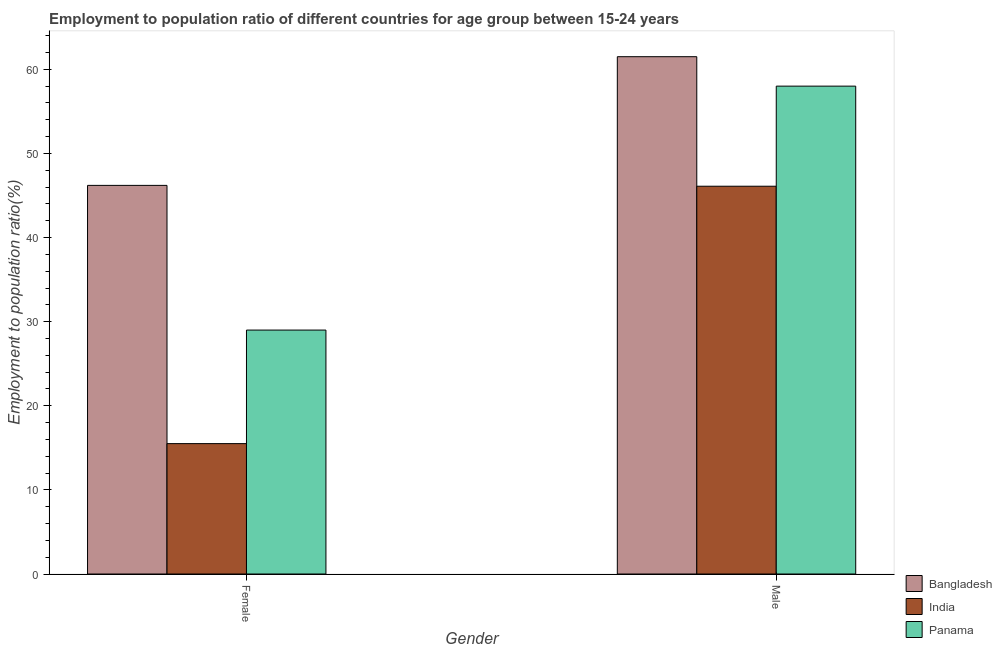How many bars are there on the 1st tick from the right?
Provide a succinct answer. 3. What is the label of the 2nd group of bars from the left?
Keep it short and to the point. Male. Across all countries, what is the maximum employment to population ratio(male)?
Make the answer very short. 61.5. Across all countries, what is the minimum employment to population ratio(male)?
Offer a terse response. 46.1. What is the total employment to population ratio(male) in the graph?
Give a very brief answer. 165.6. What is the difference between the employment to population ratio(female) in India and that in Panama?
Your response must be concise. -13.5. What is the difference between the employment to population ratio(female) in Panama and the employment to population ratio(male) in Bangladesh?
Give a very brief answer. -32.5. What is the average employment to population ratio(female) per country?
Your answer should be very brief. 30.23. What is the difference between the employment to population ratio(male) and employment to population ratio(female) in Bangladesh?
Offer a very short reply. 15.3. What is the ratio of the employment to population ratio(male) in Panama to that in Bangladesh?
Keep it short and to the point. 0.94. Is the employment to population ratio(male) in India less than that in Bangladesh?
Your answer should be very brief. Yes. In how many countries, is the employment to population ratio(male) greater than the average employment to population ratio(male) taken over all countries?
Make the answer very short. 2. How many countries are there in the graph?
Make the answer very short. 3. What is the difference between two consecutive major ticks on the Y-axis?
Give a very brief answer. 10. Are the values on the major ticks of Y-axis written in scientific E-notation?
Your answer should be very brief. No. Does the graph contain any zero values?
Your answer should be very brief. No. What is the title of the graph?
Keep it short and to the point. Employment to population ratio of different countries for age group between 15-24 years. Does "Greece" appear as one of the legend labels in the graph?
Provide a short and direct response. No. What is the label or title of the X-axis?
Give a very brief answer. Gender. What is the label or title of the Y-axis?
Offer a terse response. Employment to population ratio(%). What is the Employment to population ratio(%) in Bangladesh in Female?
Offer a very short reply. 46.2. What is the Employment to population ratio(%) of Panama in Female?
Offer a very short reply. 29. What is the Employment to population ratio(%) of Bangladesh in Male?
Offer a very short reply. 61.5. What is the Employment to population ratio(%) in India in Male?
Provide a succinct answer. 46.1. What is the Employment to population ratio(%) in Panama in Male?
Offer a very short reply. 58. Across all Gender, what is the maximum Employment to population ratio(%) of Bangladesh?
Your response must be concise. 61.5. Across all Gender, what is the maximum Employment to population ratio(%) in India?
Provide a succinct answer. 46.1. Across all Gender, what is the minimum Employment to population ratio(%) in Bangladesh?
Your answer should be compact. 46.2. Across all Gender, what is the minimum Employment to population ratio(%) in Panama?
Provide a succinct answer. 29. What is the total Employment to population ratio(%) of Bangladesh in the graph?
Make the answer very short. 107.7. What is the total Employment to population ratio(%) of India in the graph?
Ensure brevity in your answer.  61.6. What is the total Employment to population ratio(%) in Panama in the graph?
Keep it short and to the point. 87. What is the difference between the Employment to population ratio(%) in Bangladesh in Female and that in Male?
Offer a terse response. -15.3. What is the difference between the Employment to population ratio(%) in India in Female and that in Male?
Provide a succinct answer. -30.6. What is the difference between the Employment to population ratio(%) of India in Female and the Employment to population ratio(%) of Panama in Male?
Give a very brief answer. -42.5. What is the average Employment to population ratio(%) in Bangladesh per Gender?
Your response must be concise. 53.85. What is the average Employment to population ratio(%) in India per Gender?
Offer a terse response. 30.8. What is the average Employment to population ratio(%) in Panama per Gender?
Give a very brief answer. 43.5. What is the difference between the Employment to population ratio(%) of Bangladesh and Employment to population ratio(%) of India in Female?
Give a very brief answer. 30.7. What is the difference between the Employment to population ratio(%) of Bangladesh and Employment to population ratio(%) of Panama in Female?
Give a very brief answer. 17.2. What is the difference between the Employment to population ratio(%) in Bangladesh and Employment to population ratio(%) in India in Male?
Ensure brevity in your answer.  15.4. What is the difference between the Employment to population ratio(%) of Bangladesh and Employment to population ratio(%) of Panama in Male?
Give a very brief answer. 3.5. What is the difference between the Employment to population ratio(%) of India and Employment to population ratio(%) of Panama in Male?
Offer a terse response. -11.9. What is the ratio of the Employment to population ratio(%) in Bangladesh in Female to that in Male?
Your response must be concise. 0.75. What is the ratio of the Employment to population ratio(%) of India in Female to that in Male?
Your response must be concise. 0.34. What is the difference between the highest and the second highest Employment to population ratio(%) of Bangladesh?
Offer a very short reply. 15.3. What is the difference between the highest and the second highest Employment to population ratio(%) of India?
Ensure brevity in your answer.  30.6. What is the difference between the highest and the lowest Employment to population ratio(%) in India?
Offer a terse response. 30.6. What is the difference between the highest and the lowest Employment to population ratio(%) in Panama?
Make the answer very short. 29. 